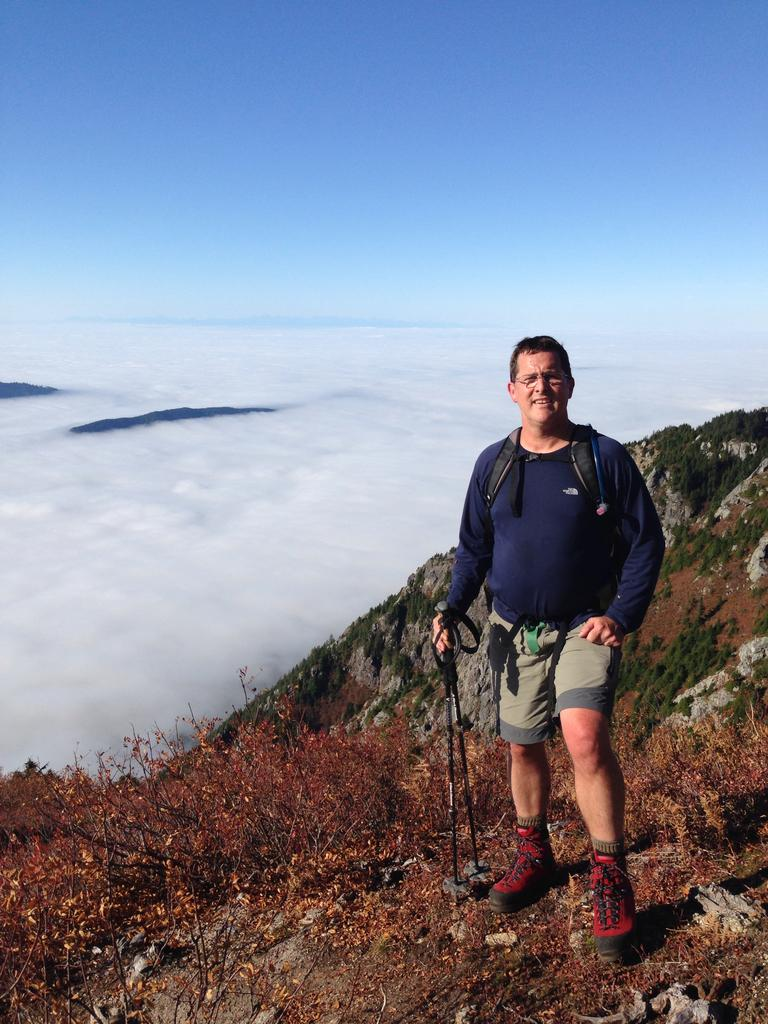What is the main subject of the image? There is a person standing in the image. What is the person holding in the image? The person is holding sticks. What type of natural environment is depicted in the image? There are plants, grass, and a rock in the image, suggesting a natural setting. Is there any water visible in the image? Yes, there is water near the rock in the image. What can be seen in the sky in the image? The sky is visible in the image. What type of humor can be seen in the person's facial expression in the image? There is no indication of humor or facial expression in the image, as it only shows a person holding sticks. Is there a volcano visible in the image? No, there is no volcano present in the image. 